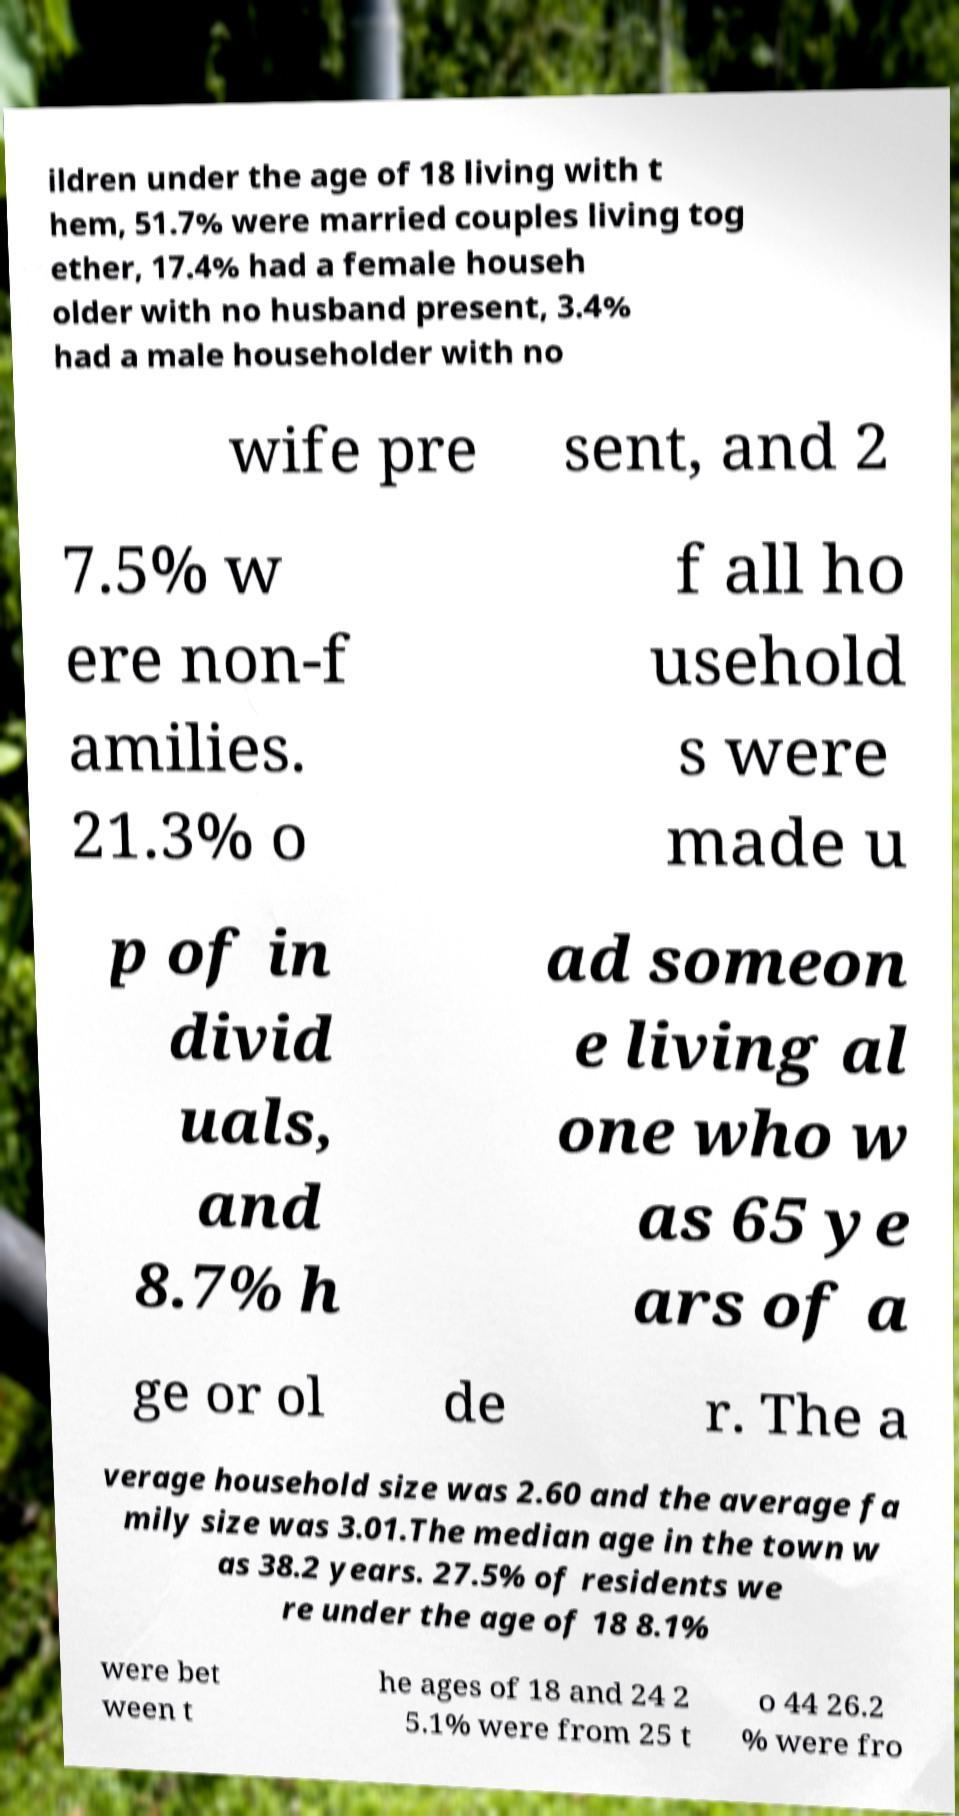What messages or text are displayed in this image? I need them in a readable, typed format. ildren under the age of 18 living with t hem, 51.7% were married couples living tog ether, 17.4% had a female househ older with no husband present, 3.4% had a male householder with no wife pre sent, and 2 7.5% w ere non-f amilies. 21.3% o f all ho usehold s were made u p of in divid uals, and 8.7% h ad someon e living al one who w as 65 ye ars of a ge or ol de r. The a verage household size was 2.60 and the average fa mily size was 3.01.The median age in the town w as 38.2 years. 27.5% of residents we re under the age of 18 8.1% were bet ween t he ages of 18 and 24 2 5.1% were from 25 t o 44 26.2 % were fro 